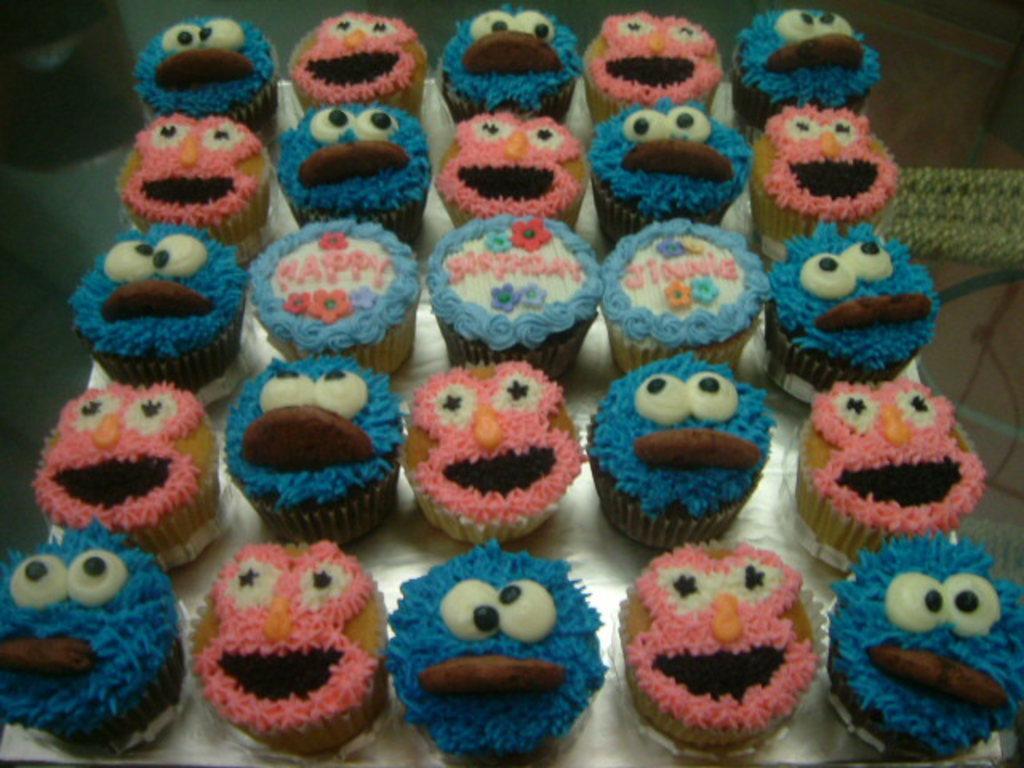Can you describe this image briefly? In this image, we can see some cupcakes on an object. We can also see some objects on the right. We can also see an object on the left. 